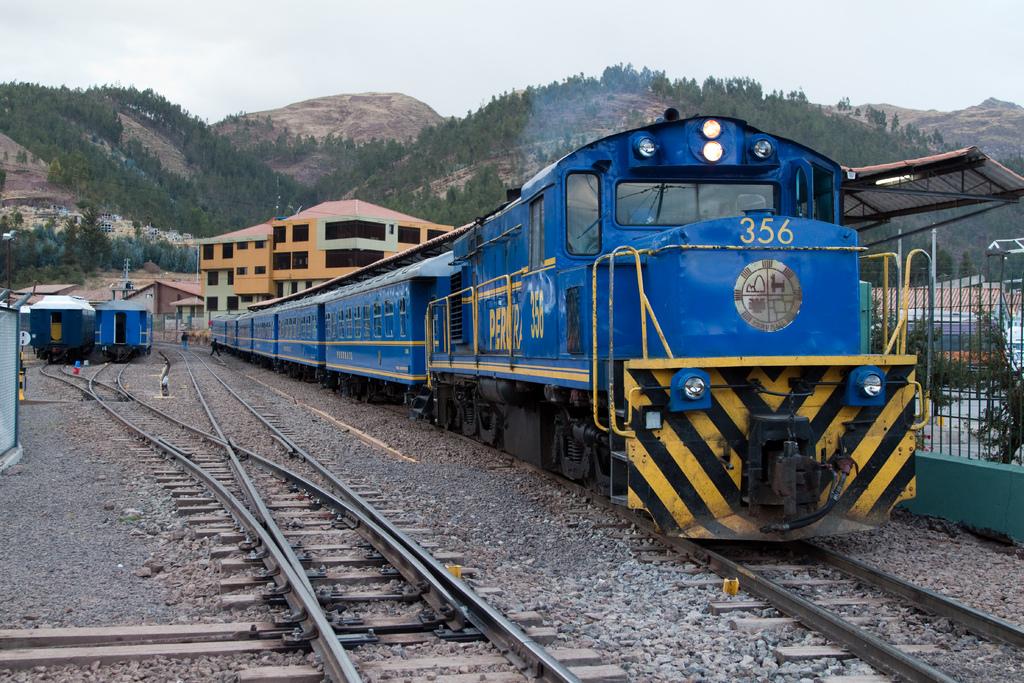What is the number of the train in the picture?
Keep it short and to the point. 356. 